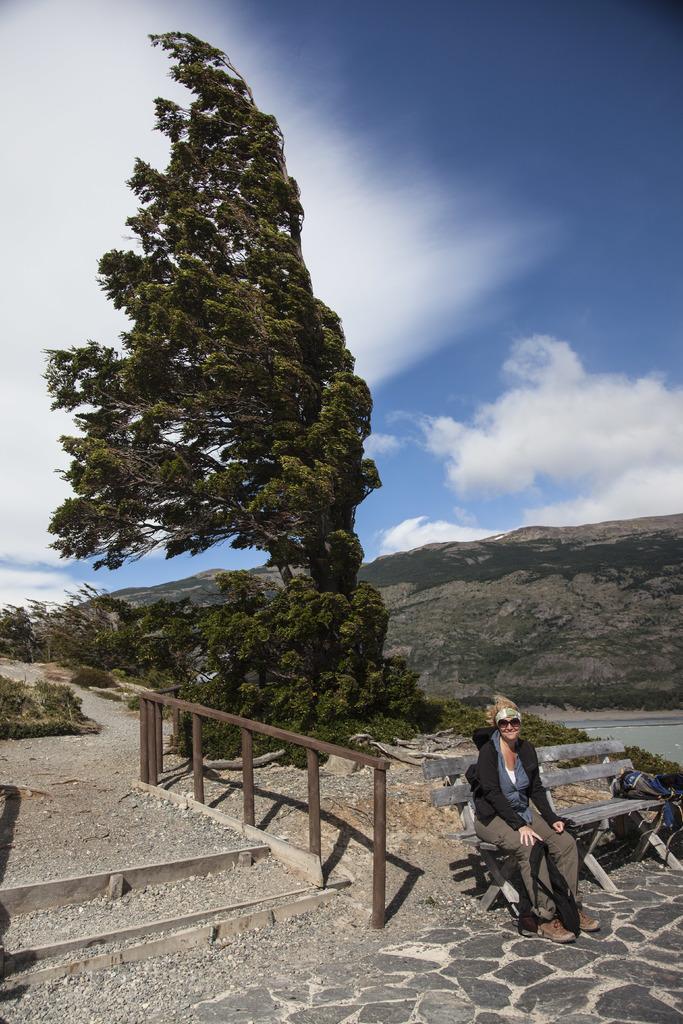Describe this image in one or two sentences. In this image there is a lady wearing goggles is sitting on the bench. Near to her there are steps with railing. In the back there are trees, hill and sky with clouds. On the bench there is bag. 